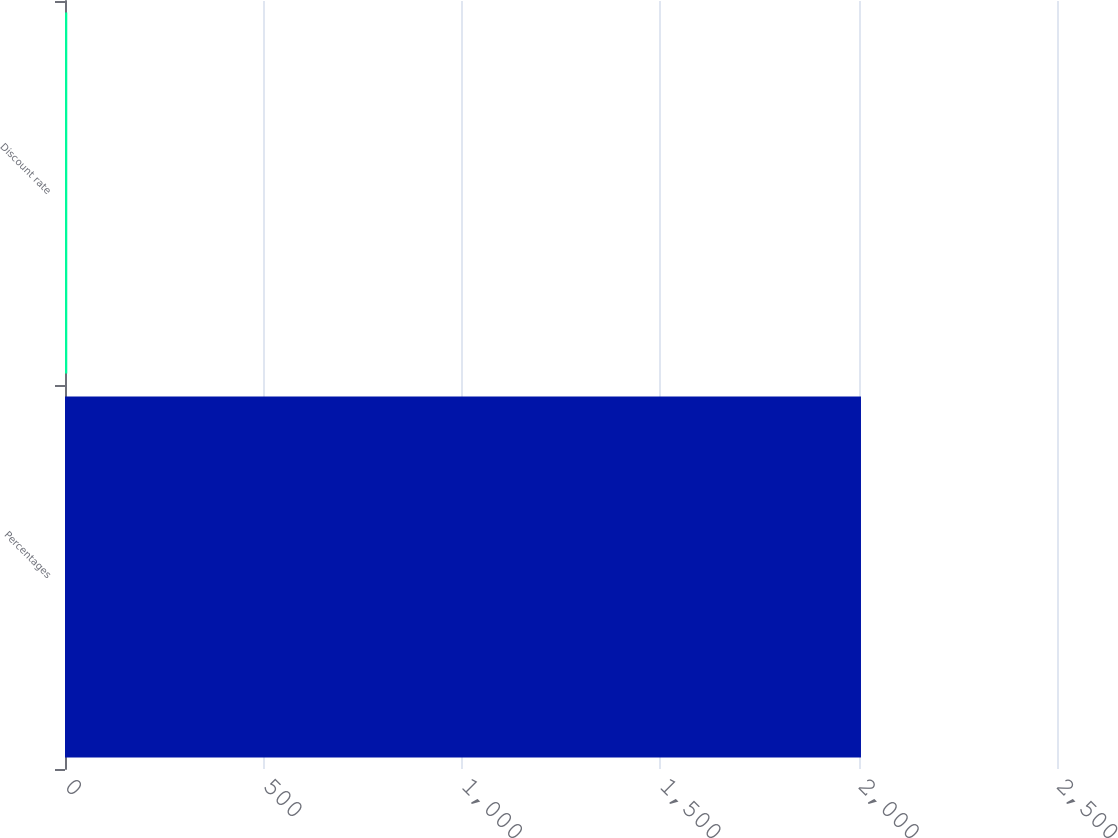<chart> <loc_0><loc_0><loc_500><loc_500><bar_chart><fcel>Percentages<fcel>Discount rate<nl><fcel>2006<fcel>5.75<nl></chart> 